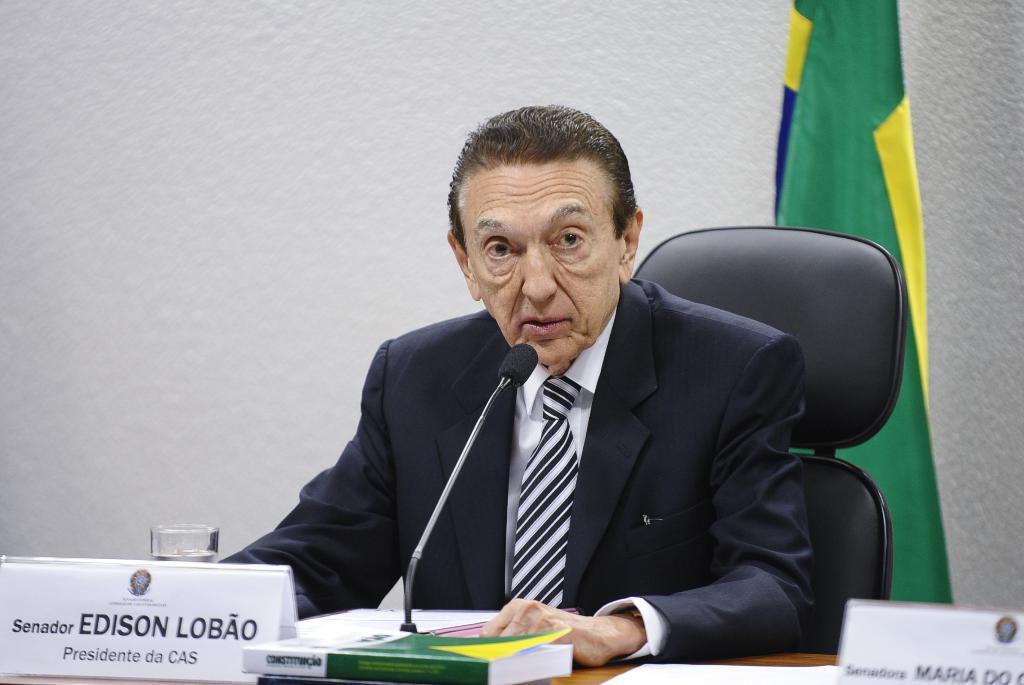In one or two sentences, can you explain what this image depicts? In this image we can see a person sitting in the chair, in front of him there is a table, on the table, we can see the books, glass, mice, and other objects. In the background, we can see a flag and a wall. 